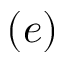<formula> <loc_0><loc_0><loc_500><loc_500>( e )</formula> 